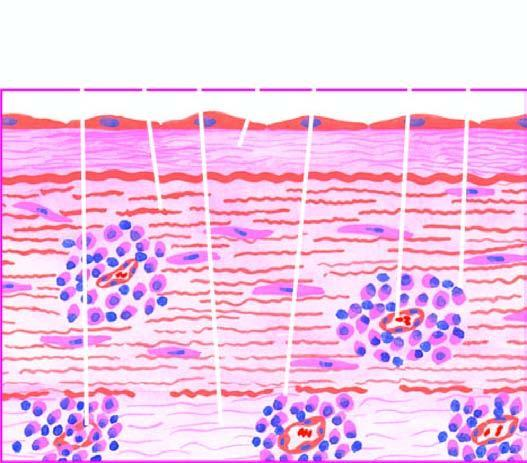s there perivascular infiltrate of plasma cells, lymphocytes and macrophages?
Answer the question using a single word or phrase. Yes 